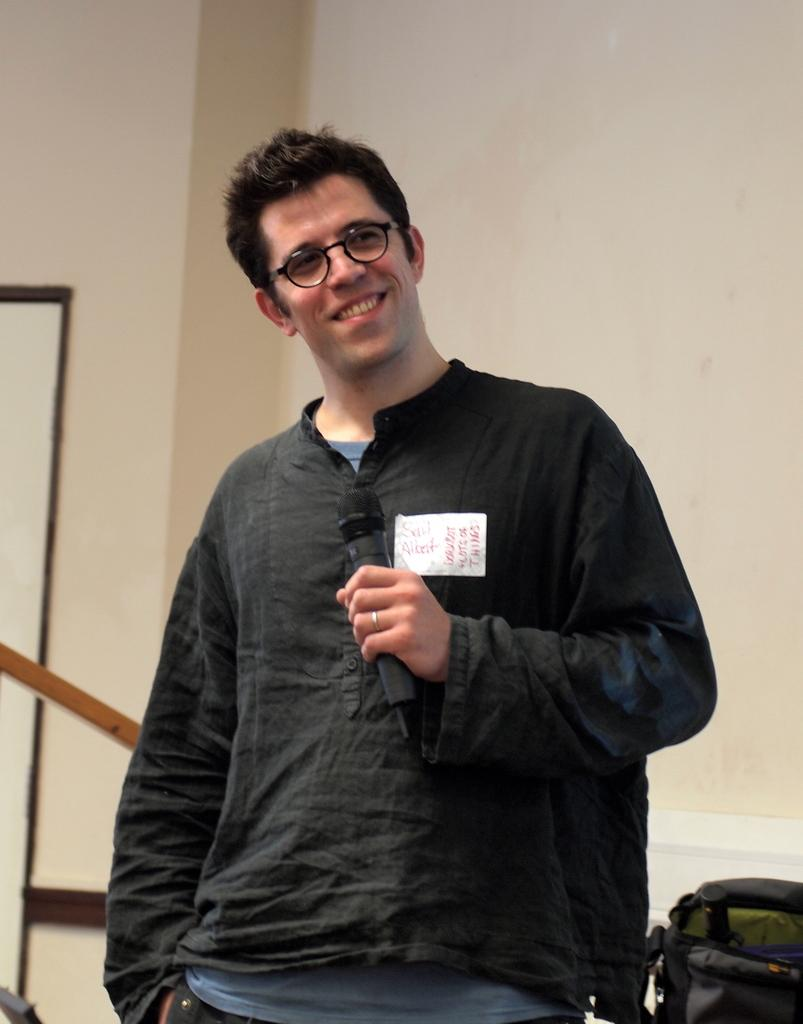What is the man in the image doing? The man is standing in the image and holding a microphone in his hand. What can be seen on the man's face in the image? The man is wearing spectacles in the image. What object is present in the image besides the man and his microphone? There is a bag in the image. What is visible in the background of the image? There is a wall in the background of the image. How does the man control the water in the image? There is no water present in the image, so the man cannot control any water. 